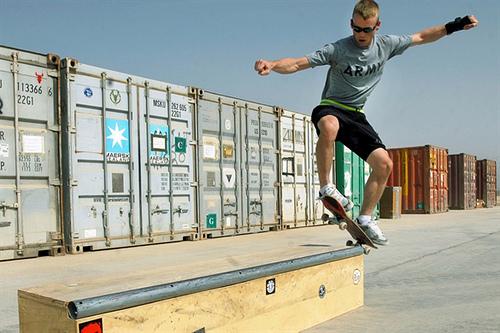What is the man riding?
Write a very short answer. Skateboard. What is on his right elbow?
Quick response, please. Nothing. What action is this person performing?
Write a very short answer. Skateboarding. Which armed service does he like?
Keep it brief. Army. 